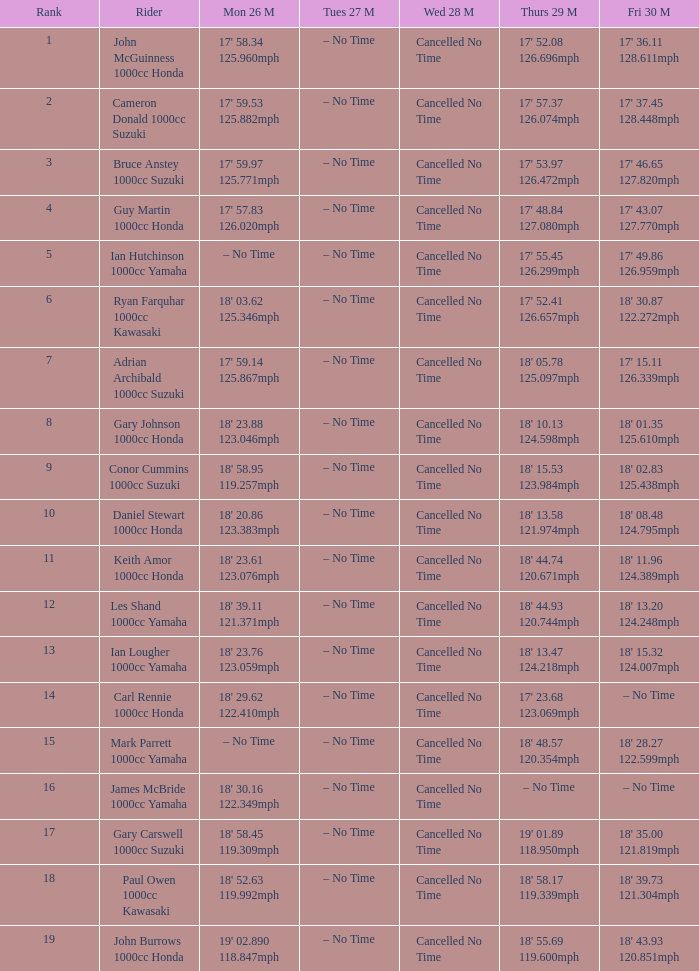What tims is wed may 28 and mon may 26 is 17' 58.34 125.960mph? Cancelled No Time. 